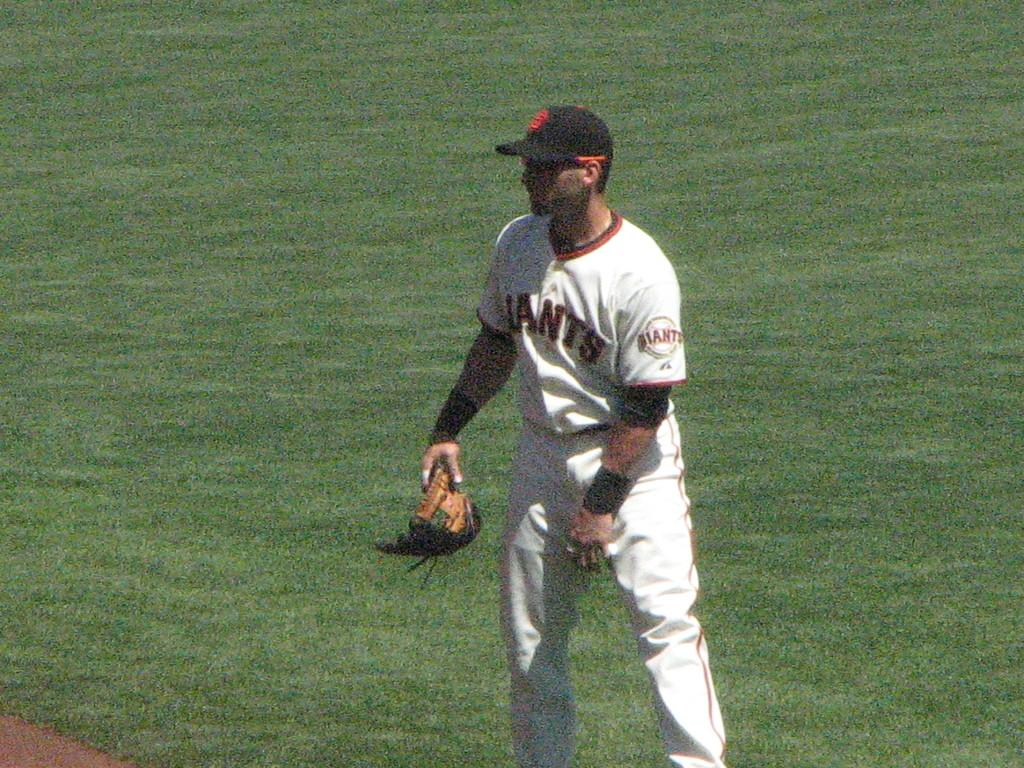Provide a one-sentence caption for the provided image. A Giants player stands at the edge of the diamond  waiting to play. 